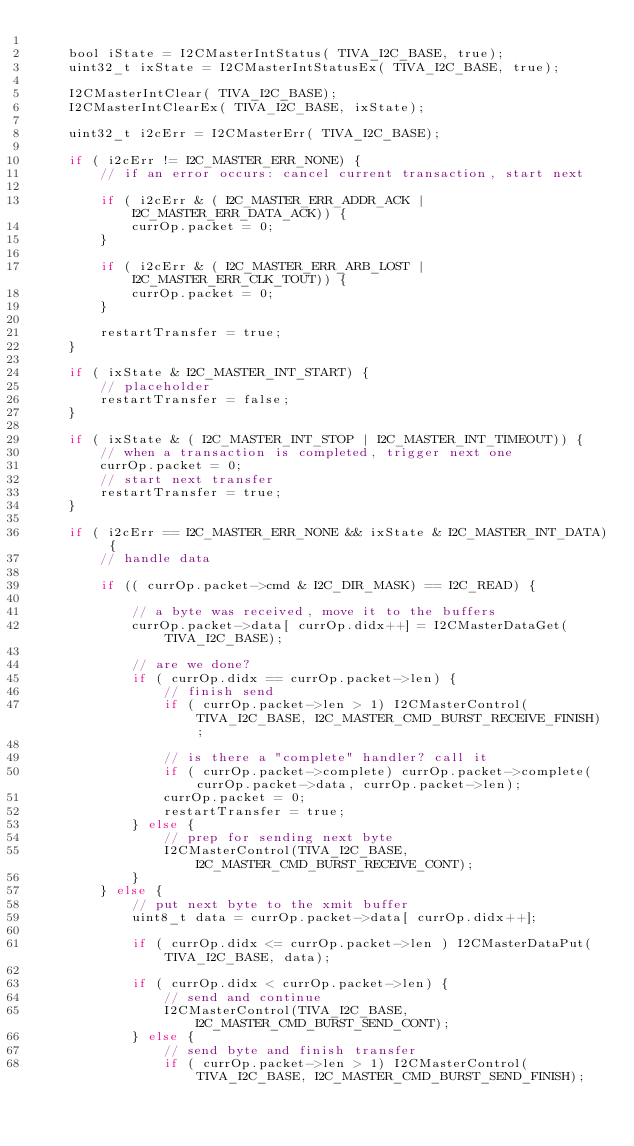Convert code to text. <code><loc_0><loc_0><loc_500><loc_500><_C_>
	bool iState = I2CMasterIntStatus( TIVA_I2C_BASE, true);
	uint32_t ixState = I2CMasterIntStatusEx( TIVA_I2C_BASE, true);

	I2CMasterIntClear( TIVA_I2C_BASE);
	I2CMasterIntClearEx( TIVA_I2C_BASE, ixState);

	uint32_t i2cErr = I2CMasterErr( TIVA_I2C_BASE);

	if ( i2cErr != I2C_MASTER_ERR_NONE) {
		// if an error occurs: cancel current transaction, start next

		if ( i2cErr & ( I2C_MASTER_ERR_ADDR_ACK | I2C_MASTER_ERR_DATA_ACK)) {
			currOp.packet = 0;
		}

		if ( i2cErr & ( I2C_MASTER_ERR_ARB_LOST | I2C_MASTER_ERR_CLK_TOUT)) {
			currOp.packet = 0;
		}

		restartTransfer = true;
	}

	if ( ixState & I2C_MASTER_INT_START) {
		// placeholder
		restartTransfer = false;
	}

	if ( ixState & ( I2C_MASTER_INT_STOP | I2C_MASTER_INT_TIMEOUT)) {
		// when a transaction is completed, trigger next one
		currOp.packet = 0;
		// start next transfer
		restartTransfer = true;
	}

	if ( i2cErr == I2C_MASTER_ERR_NONE && ixState & I2C_MASTER_INT_DATA) {
        // handle data

		if (( currOp.packet->cmd & I2C_DIR_MASK) == I2C_READ) {

			// a byte was received, move it to the buffers
			currOp.packet->data[ currOp.didx++] = I2CMasterDataGet(TIVA_I2C_BASE);

			// are we done?
			if ( currOp.didx == currOp.packet->len) {
				// finish send
				if ( currOp.packet->len > 1) I2CMasterControl(TIVA_I2C_BASE, I2C_MASTER_CMD_BURST_RECEIVE_FINISH);

				// is there a "complete" handler? call it
				if ( currOp.packet->complete) currOp.packet->complete( currOp.packet->data, currOp.packet->len);
				currOp.packet = 0;
				restartTransfer = true;
			} else {
				// prep for sending next byte
				I2CMasterControl(TIVA_I2C_BASE, I2C_MASTER_CMD_BURST_RECEIVE_CONT);
			}
		} else {
			// put next byte to the xmit buffer
			uint8_t data = currOp.packet->data[ currOp.didx++];

			if ( currOp.didx <= currOp.packet->len ) I2CMasterDataPut(TIVA_I2C_BASE, data);

			if ( currOp.didx < currOp.packet->len) {
				// send and continue
				I2CMasterControl(TIVA_I2C_BASE, I2C_MASTER_CMD_BURST_SEND_CONT);
			} else {
				// send byte and finish transfer
				if ( currOp.packet->len > 1) I2CMasterControl(TIVA_I2C_BASE, I2C_MASTER_CMD_BURST_SEND_FINISH);
</code> 